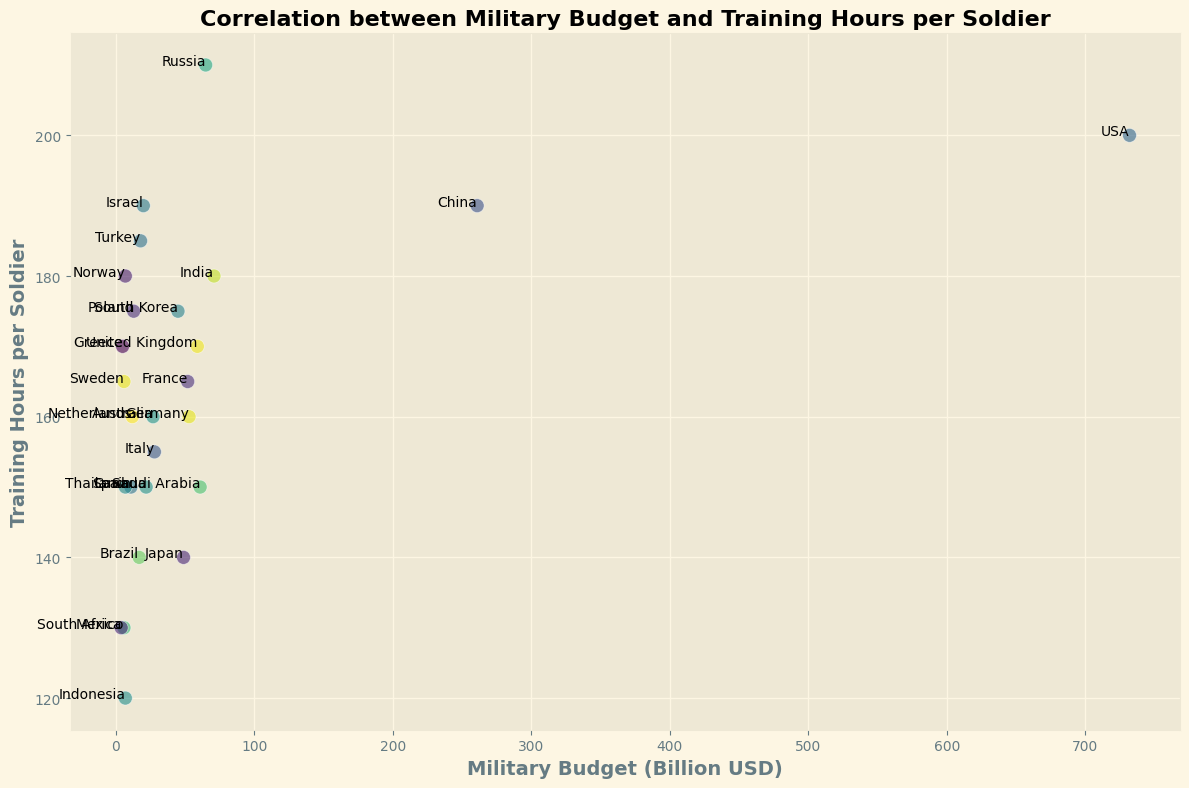Which country has the highest military budget? From the scatter plot, locate the point farthest to the right, which represents the highest military budget. The point is labeled "USA".
Answer: USA Which country has the lowest training hours per soldier? Find the point located lowest on the y-axis, representing the fewest training hours per soldier. The point is labeled "Indonesia".
Answer: Indonesia How does the training time of Saudi Arabian soldiers compare to that of South Korean soldiers? Locate Saudi Arabia and South Korea on the plot and compare their y-axis positions. South Korea is higher up than Saudi Arabia, indicating more training hours per soldier.
Answer: South Korea has more training hours than Saudi Arabia Which country has the second highest military budget? Identify the second point from the right on the x-axis of the scatter plot. The point represents China.
Answer: China What is the average training hours per soldier for the countries with a military budget below 50 billion USD? Identify the countries with a military budget less than 50 billion USD and find their average y-axis values. The countries are: South Korea (175), Italy (155), Australia (160), Canada (150), Israel (190), Turkey (185), Brazil (140), Netherlands (160), Spain (150), Mexico (130), Indonesia (120), Poland (175), Sweden (165), Norway (180), Greece (170), South Africa (130), Thailand (150). Average = (175+155+160+150+190+185+140+160+150+130+120+175+165+180+170+130+150) / 17 ≈ 158.53
Answer: Approximately 158.53 Which European country has the highest training hours per soldier? Identify and compare the training hours (y-axis values) of European countries in the plot. Russia has the highest training hours per soldier with 210 hours.
Answer: Russia Is there a positive correlation between military budget and training hours per soldier? Visually assess the scatter plot to determine if there is an upward trend from left to right. Points are somewhat scattered, showing no clear positive correlation.
Answer: No Which two countries have the closest training hours per soldier but different military budgets? Locate points that are close on the y-axis but have different x-axis values. Turkey (185 hours) and India (180 hours) are close in training hours but have different military budgets of 18 and 71 billion USD respectively.
Answer: Turkey and India 